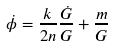Convert formula to latex. <formula><loc_0><loc_0><loc_500><loc_500>\dot { \phi } = \frac { k } { 2 n } \frac { \dot { G } } { G } + \frac { m } { G }</formula> 